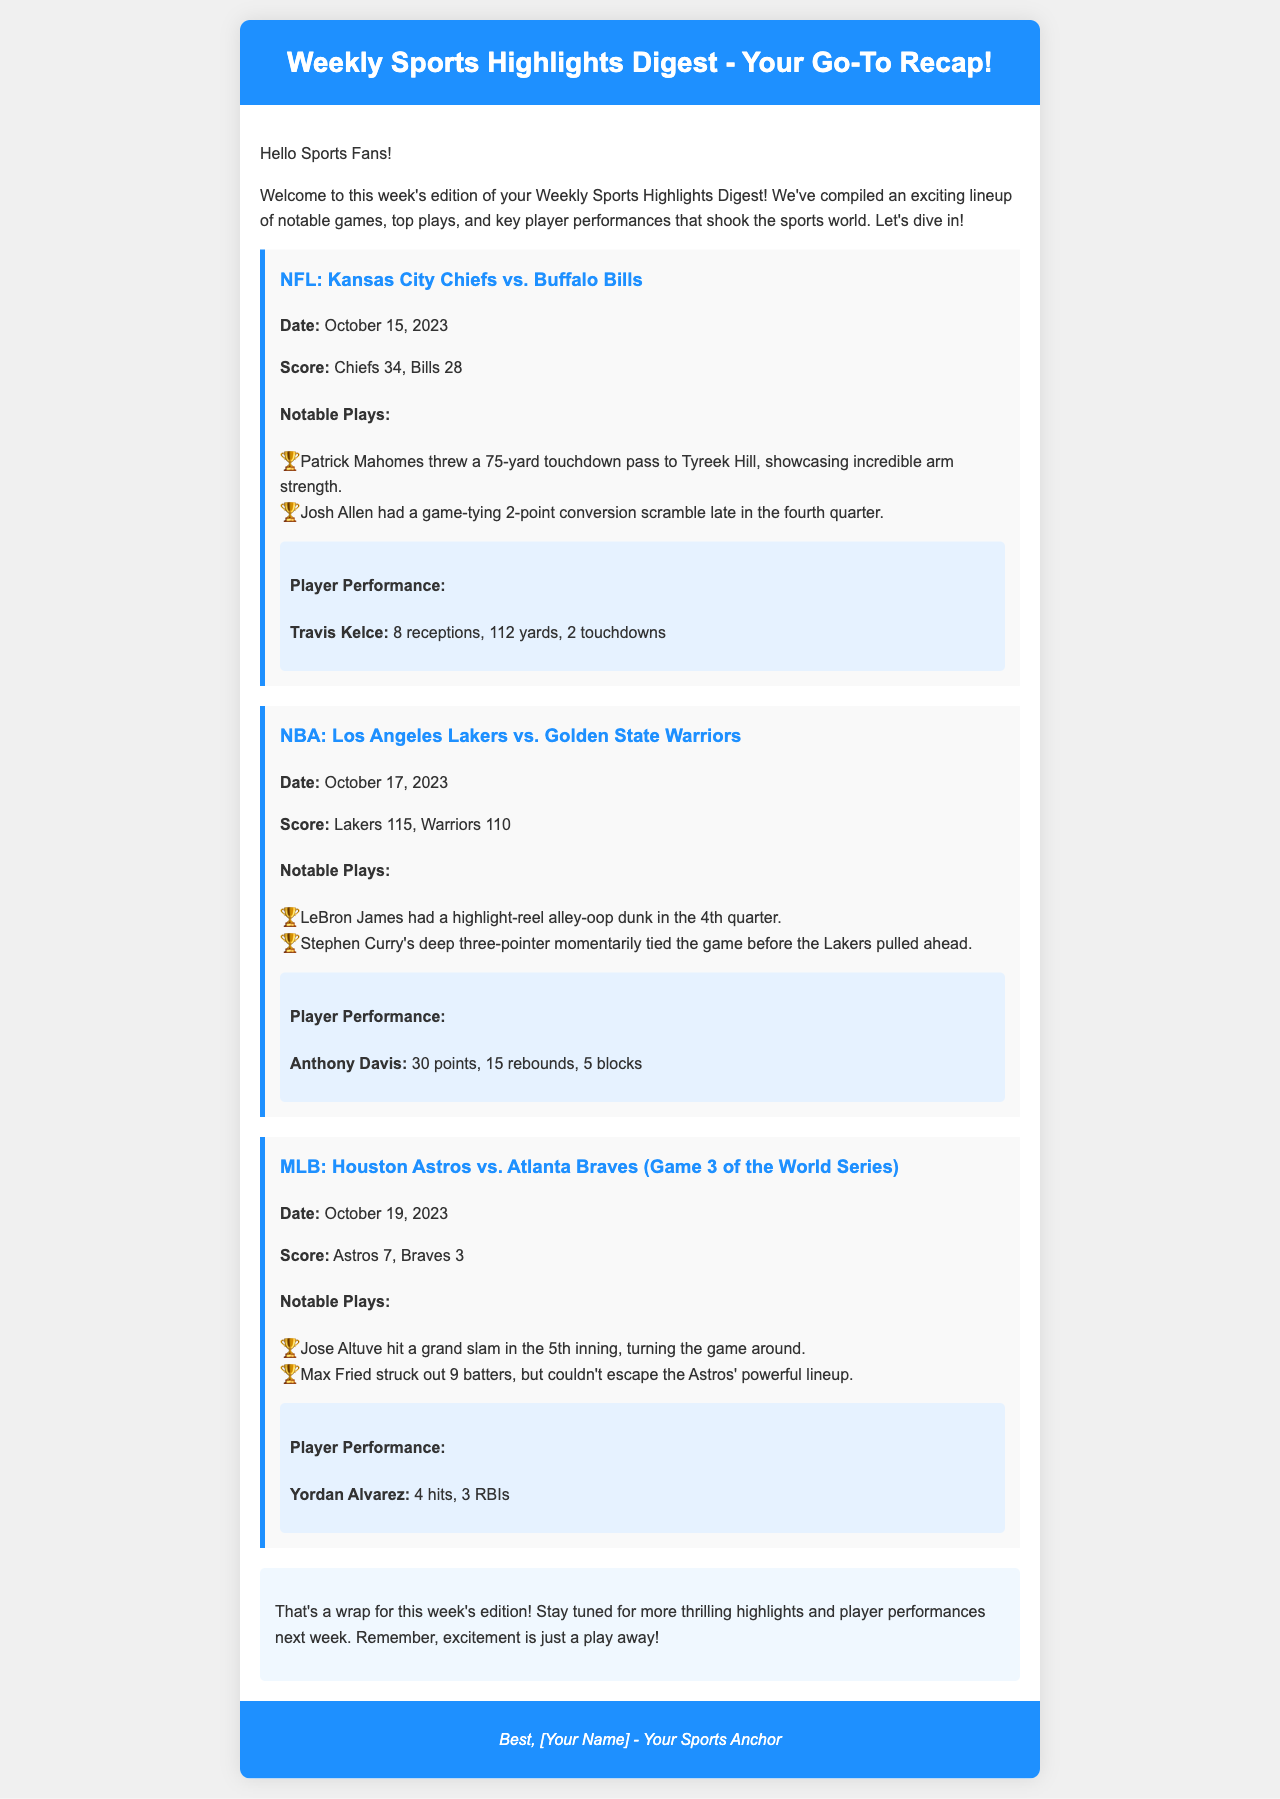What was the score of the Chiefs vs. Bills game? The score is presented in the NFL highlight section under "Score."
Answer: Chiefs 34, Bills 28 Who scored the grand slam for the Astros in Game 3 of the World Series? The highlight section for the MLB game mentions Jose Altuve's grand slam.
Answer: Jose Altuve How many points did Anthony Davis score in the Lakers vs. Warriors game? The player performance section for the NBA game indicates Anthony Davis' points.
Answer: 30 points What notable play did Patrick Mahomes make against the Bills? The notable plays section mentions a specific throw by Patrick Mahomes.
Answer: 75-yard touchdown pass to Tyreek Hill What date was the Lakers vs. Warriors game played? The date is provided in the match details of the NBA highlight section.
Answer: October 17, 2023 How many RBIs did Yordan Alvarez achieve in the World Series game? The player performance section for the MLB game includes Yordan Alvarez's stats.
Answer: 3 RBIs What was the outcome of the NFL game between the Chiefs and Bills? The score provided under the NFL highlight indicates the winning team.
Answer: Chiefs won What was the main theme of the Weekly Sports Highlights Digest? The introduction of the document outlines the purpose and contents of the digest.
Answer: Notable games, top plays, and key player performances 